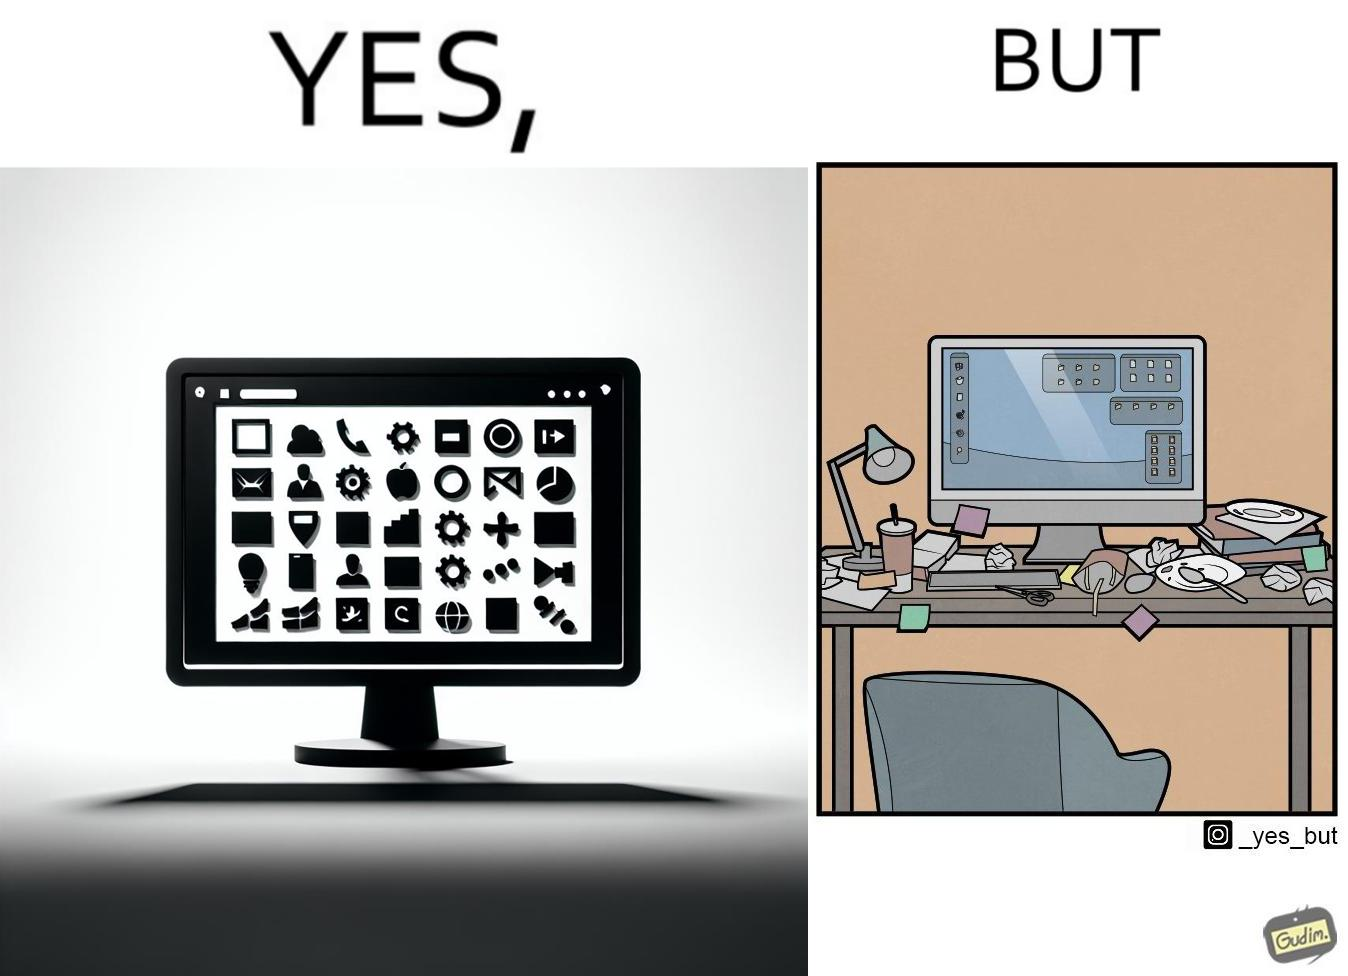Is this a satirical image? Yes, this image is satirical. 